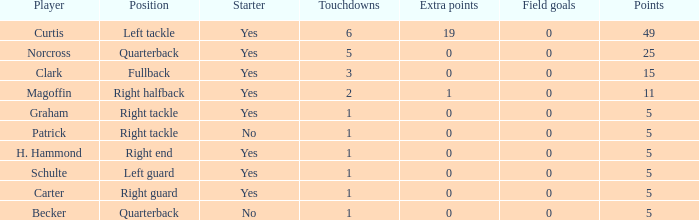Specify the maximum touchdowns scored by becker. 1.0. 